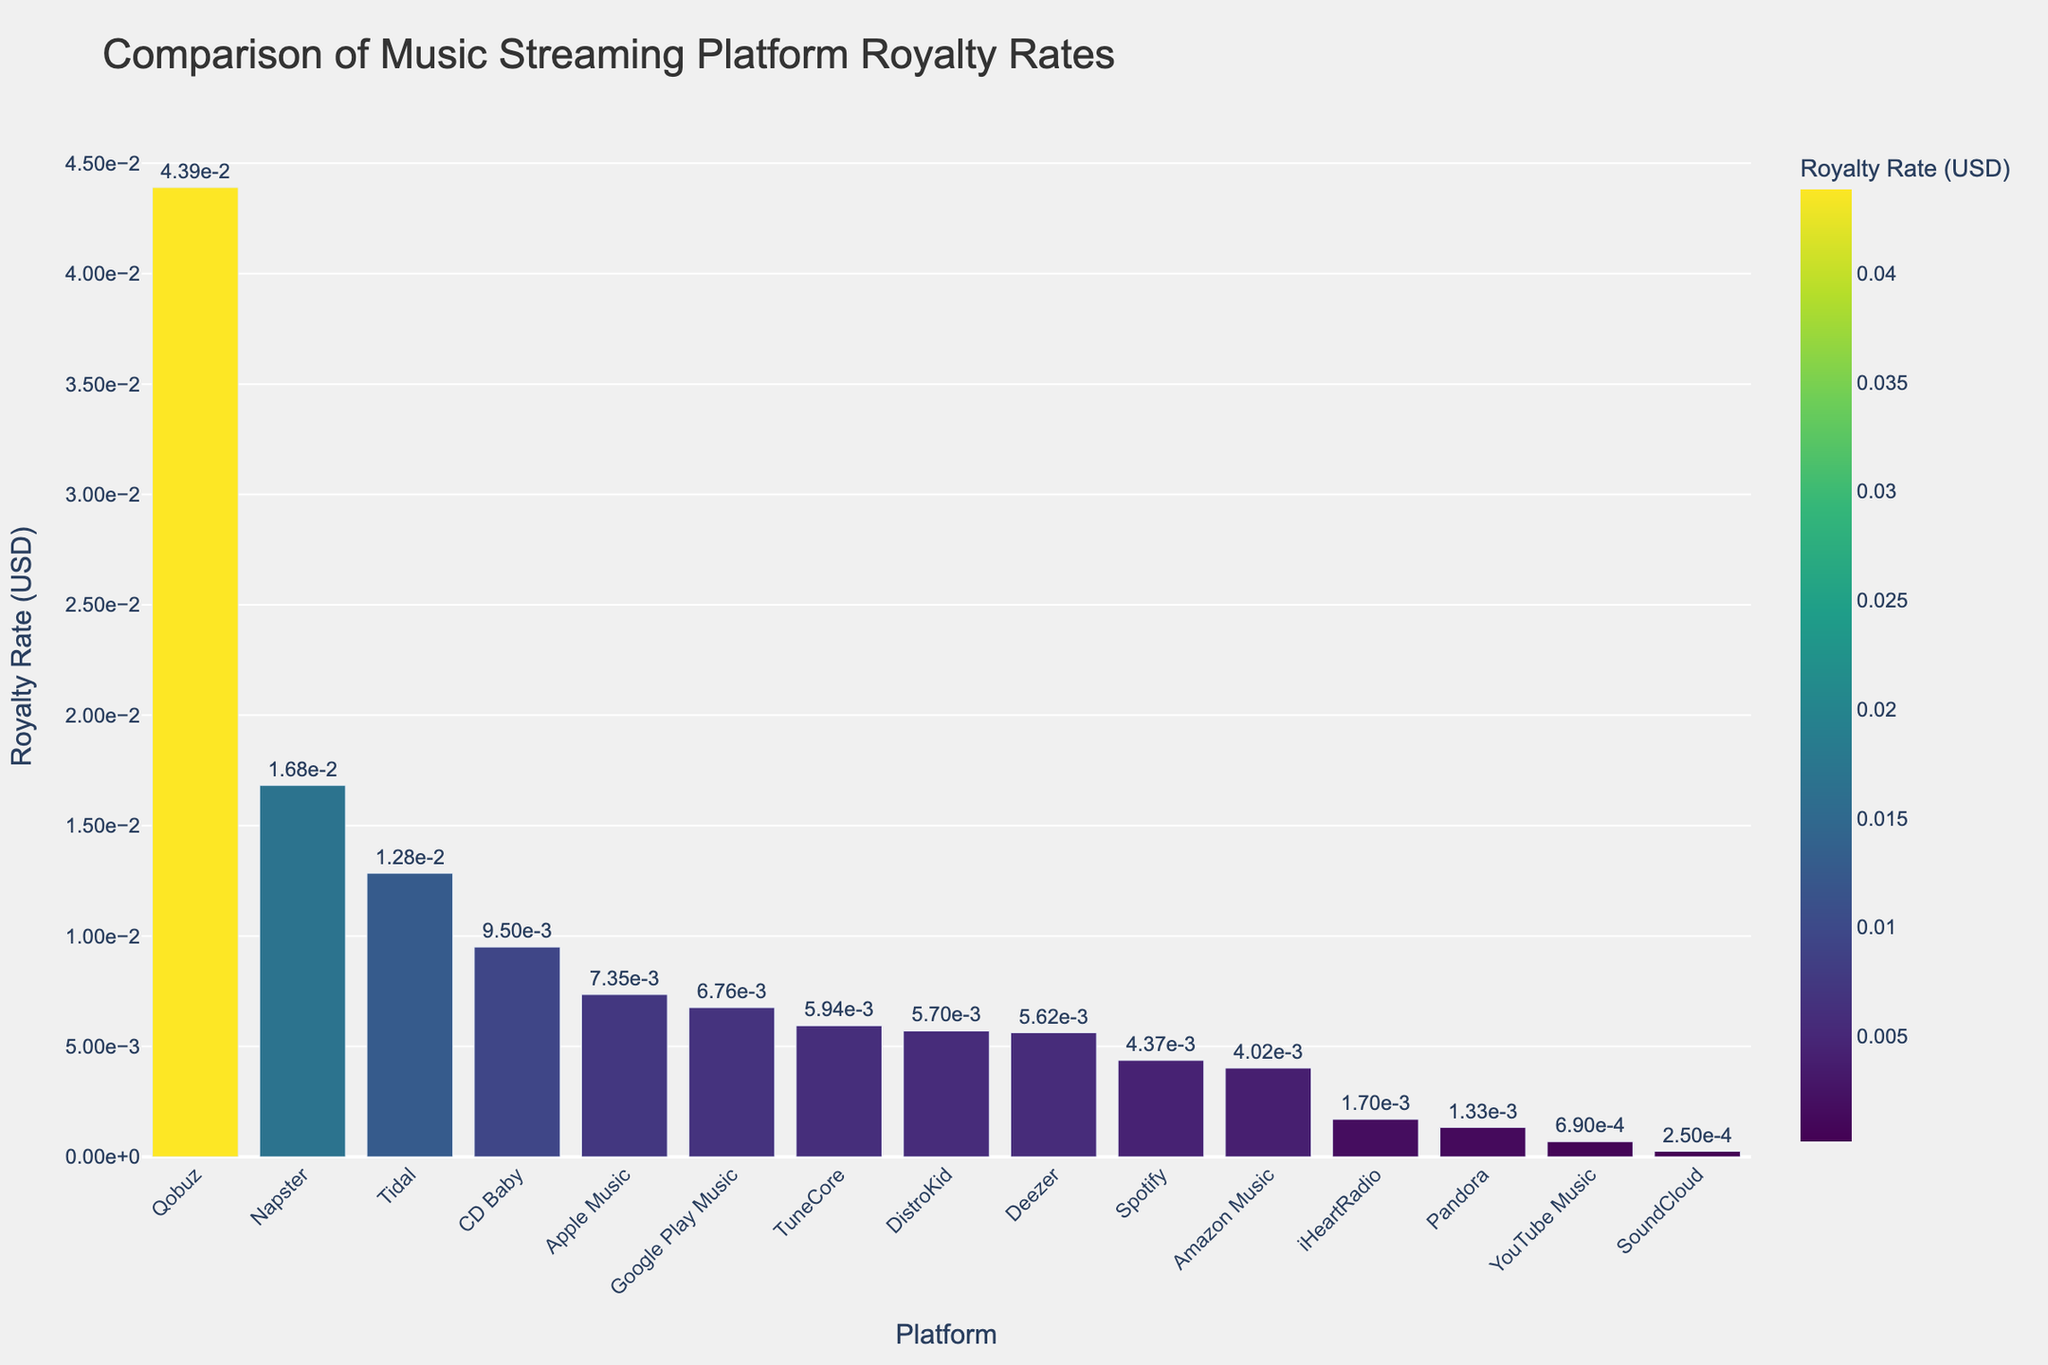Which platform has the highest royalty rate per stream? To determine the platform with the highest royalty rate per stream, look for the bar that is the tallest in the chart. Qobuz has the highest bar, indicating it has the highest rate.
Answer: Qobuz How does the royalty rate of Tidal compare to Spotify? To compare Tidal and Spotify, observe the height of their respective bars. Tidal's bar is taller than Spotify's, meaning Tidal’s royalty rate is higher.
Answer: Tidal's rate is higher What is the difference in royalty rate per stream between SoundCloud and Napster? Find the height of the bars for SoundCloud and Napster. Napster's rate is approximately 0.01682 USD, while SoundCloud's is around 0.00025 USD. Subtract SoundCloud's rate from Napster's rate: 0.01682 - 0.00025.
Answer: 0.01657 USD Which platforms have royalty rates higher than 0.01 USD per stream? Identify all the bars that are higher than the line indicating the 0.01 USD mark. These are Tidal, Napster, and Qobuz.
Answer: Tidal, Napster, Qobuz What is the average royalty rate per stream for Deezer, CD Baby, and Pandora? Sum the royalty rates for Deezer, CD Baby, and Pandora: 0.00562 + 0.00950 + 0.00133. Then, divide by 3 to find the average: (0.00562 + 0.00950 + 0.00133) / 3.
Answer: 0.00548 USD How much greater is Apple Music's royalty rate compared to YouTube Music? Find the rates for Apple Music and YouTube Music: 0.00735 and 0.00069, respectively. Subtract YouTube Music's rate from Apple Music's rate: 0.00735 - 0.00069.
Answer: 0.00666 USD Which platform has nearly the same royalty rate as DistroKid? Look for the bar that is about the same height as DistroKid's bar (0.00570 USD). TuneCore has a rate of 0.00594 USD, which is nearest to DistroKid's.
Answer: TuneCore Is there more than one platform with a royalty rate between 0.004 and 0.006 USD per stream? Check all the bars that fall within the 0.004 to 0.006 USD range. Platforms in this range are Spotify, Deezer, Amazon Music, and DistroKid. Yes, there are more than one.
Answer: Yes Which platform has the lowest royalty rate, and what is it? Identify the platform with the shortest bar; this represents SoundCloud. Its rate is the lowest.
Answer: SoundCloud, 0.00025 USD 